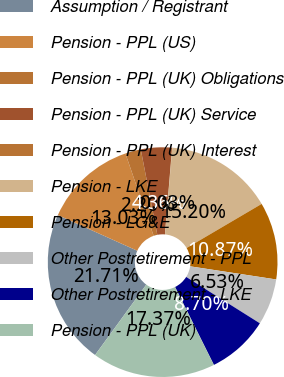Convert chart to OTSL. <chart><loc_0><loc_0><loc_500><loc_500><pie_chart><fcel>Assumption / Registrant<fcel>Pension - PPL (US)<fcel>Pension - PPL (UK) Obligations<fcel>Pension - PPL (UK) Service<fcel>Pension - PPL (UK) Interest<fcel>Pension - LKE<fcel>Pension - LG&E<fcel>Other Postretirement - PPL<fcel>Other Postretirement - LKE<fcel>Pension - PPL (UK)<nl><fcel>21.71%<fcel>13.03%<fcel>2.2%<fcel>4.36%<fcel>0.03%<fcel>15.2%<fcel>10.87%<fcel>6.53%<fcel>8.7%<fcel>17.37%<nl></chart> 